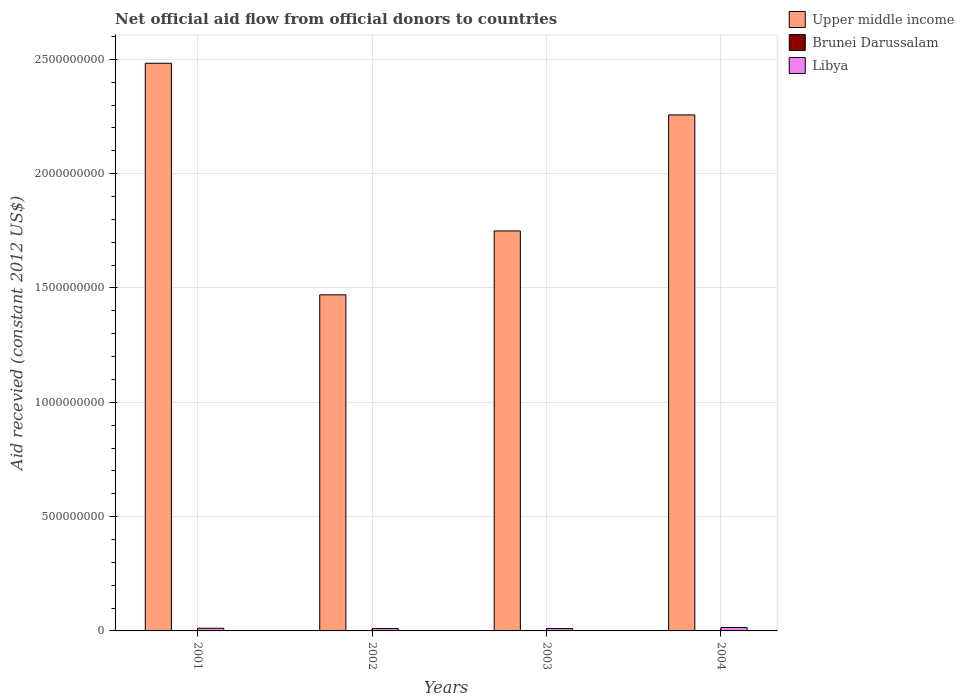In how many cases, is the number of bars for a given year not equal to the number of legend labels?
Ensure brevity in your answer.  1. What is the total aid received in Libya in 2001?
Provide a succinct answer. 1.17e+07. Across all years, what is the maximum total aid received in Libya?
Give a very brief answer. 1.50e+07. Across all years, what is the minimum total aid received in Libya?
Provide a short and direct response. 1.03e+07. In which year was the total aid received in Libya maximum?
Provide a succinct answer. 2004. What is the total total aid received in Brunei Darussalam in the graph?
Offer a terse response. 2.14e+06. What is the difference between the total aid received in Brunei Darussalam in 2001 and that in 2004?
Your answer should be very brief. -3.40e+05. What is the difference between the total aid received in Libya in 2003 and the total aid received in Brunei Darussalam in 2002?
Ensure brevity in your answer.  1.03e+07. What is the average total aid received in Brunei Darussalam per year?
Ensure brevity in your answer.  5.35e+05. In the year 2003, what is the difference between the total aid received in Brunei Darussalam and total aid received in Upper middle income?
Provide a succinct answer. -1.75e+09. What is the ratio of the total aid received in Upper middle income in 2001 to that in 2002?
Offer a very short reply. 1.69. What is the difference between the highest and the second highest total aid received in Brunei Darussalam?
Keep it short and to the point. 3.40e+05. What is the difference between the highest and the lowest total aid received in Brunei Darussalam?
Make the answer very short. 9.40e+05. How many bars are there?
Make the answer very short. 11. Are all the bars in the graph horizontal?
Your answer should be very brief. No. How many years are there in the graph?
Ensure brevity in your answer.  4. What is the difference between two consecutive major ticks on the Y-axis?
Provide a short and direct response. 5.00e+08. Where does the legend appear in the graph?
Keep it short and to the point. Top right. How many legend labels are there?
Keep it short and to the point. 3. What is the title of the graph?
Offer a terse response. Net official aid flow from official donors to countries. What is the label or title of the Y-axis?
Provide a succinct answer. Aid recevied (constant 2012 US$). What is the Aid recevied (constant 2012 US$) of Upper middle income in 2001?
Your answer should be very brief. 2.48e+09. What is the Aid recevied (constant 2012 US$) in Libya in 2001?
Make the answer very short. 1.17e+07. What is the Aid recevied (constant 2012 US$) in Upper middle income in 2002?
Ensure brevity in your answer.  1.47e+09. What is the Aid recevied (constant 2012 US$) in Brunei Darussalam in 2002?
Ensure brevity in your answer.  0. What is the Aid recevied (constant 2012 US$) of Libya in 2002?
Ensure brevity in your answer.  1.05e+07. What is the Aid recevied (constant 2012 US$) of Upper middle income in 2003?
Offer a terse response. 1.75e+09. What is the Aid recevied (constant 2012 US$) in Brunei Darussalam in 2003?
Make the answer very short. 6.00e+05. What is the Aid recevied (constant 2012 US$) of Libya in 2003?
Your response must be concise. 1.03e+07. What is the Aid recevied (constant 2012 US$) in Upper middle income in 2004?
Ensure brevity in your answer.  2.26e+09. What is the Aid recevied (constant 2012 US$) of Brunei Darussalam in 2004?
Your answer should be very brief. 9.40e+05. What is the Aid recevied (constant 2012 US$) of Libya in 2004?
Your answer should be compact. 1.50e+07. Across all years, what is the maximum Aid recevied (constant 2012 US$) of Upper middle income?
Your response must be concise. 2.48e+09. Across all years, what is the maximum Aid recevied (constant 2012 US$) of Brunei Darussalam?
Keep it short and to the point. 9.40e+05. Across all years, what is the maximum Aid recevied (constant 2012 US$) in Libya?
Offer a very short reply. 1.50e+07. Across all years, what is the minimum Aid recevied (constant 2012 US$) in Upper middle income?
Provide a succinct answer. 1.47e+09. Across all years, what is the minimum Aid recevied (constant 2012 US$) in Libya?
Give a very brief answer. 1.03e+07. What is the total Aid recevied (constant 2012 US$) in Upper middle income in the graph?
Provide a short and direct response. 7.96e+09. What is the total Aid recevied (constant 2012 US$) of Brunei Darussalam in the graph?
Provide a succinct answer. 2.14e+06. What is the total Aid recevied (constant 2012 US$) of Libya in the graph?
Offer a very short reply. 4.76e+07. What is the difference between the Aid recevied (constant 2012 US$) of Upper middle income in 2001 and that in 2002?
Give a very brief answer. 1.01e+09. What is the difference between the Aid recevied (constant 2012 US$) of Libya in 2001 and that in 2002?
Make the answer very short. 1.22e+06. What is the difference between the Aid recevied (constant 2012 US$) of Upper middle income in 2001 and that in 2003?
Your answer should be very brief. 7.33e+08. What is the difference between the Aid recevied (constant 2012 US$) in Libya in 2001 and that in 2003?
Provide a succinct answer. 1.39e+06. What is the difference between the Aid recevied (constant 2012 US$) in Upper middle income in 2001 and that in 2004?
Offer a very short reply. 2.26e+08. What is the difference between the Aid recevied (constant 2012 US$) of Libya in 2001 and that in 2004?
Make the answer very short. -3.28e+06. What is the difference between the Aid recevied (constant 2012 US$) of Upper middle income in 2002 and that in 2003?
Ensure brevity in your answer.  -2.79e+08. What is the difference between the Aid recevied (constant 2012 US$) of Upper middle income in 2002 and that in 2004?
Offer a terse response. -7.87e+08. What is the difference between the Aid recevied (constant 2012 US$) of Libya in 2002 and that in 2004?
Your response must be concise. -4.50e+06. What is the difference between the Aid recevied (constant 2012 US$) in Upper middle income in 2003 and that in 2004?
Ensure brevity in your answer.  -5.07e+08. What is the difference between the Aid recevied (constant 2012 US$) in Libya in 2003 and that in 2004?
Your answer should be compact. -4.67e+06. What is the difference between the Aid recevied (constant 2012 US$) in Upper middle income in 2001 and the Aid recevied (constant 2012 US$) in Libya in 2002?
Your answer should be very brief. 2.47e+09. What is the difference between the Aid recevied (constant 2012 US$) in Brunei Darussalam in 2001 and the Aid recevied (constant 2012 US$) in Libya in 2002?
Your answer should be compact. -9.91e+06. What is the difference between the Aid recevied (constant 2012 US$) in Upper middle income in 2001 and the Aid recevied (constant 2012 US$) in Brunei Darussalam in 2003?
Offer a very short reply. 2.48e+09. What is the difference between the Aid recevied (constant 2012 US$) of Upper middle income in 2001 and the Aid recevied (constant 2012 US$) of Libya in 2003?
Your answer should be very brief. 2.47e+09. What is the difference between the Aid recevied (constant 2012 US$) in Brunei Darussalam in 2001 and the Aid recevied (constant 2012 US$) in Libya in 2003?
Offer a terse response. -9.74e+06. What is the difference between the Aid recevied (constant 2012 US$) of Upper middle income in 2001 and the Aid recevied (constant 2012 US$) of Brunei Darussalam in 2004?
Offer a very short reply. 2.48e+09. What is the difference between the Aid recevied (constant 2012 US$) of Upper middle income in 2001 and the Aid recevied (constant 2012 US$) of Libya in 2004?
Keep it short and to the point. 2.47e+09. What is the difference between the Aid recevied (constant 2012 US$) of Brunei Darussalam in 2001 and the Aid recevied (constant 2012 US$) of Libya in 2004?
Ensure brevity in your answer.  -1.44e+07. What is the difference between the Aid recevied (constant 2012 US$) in Upper middle income in 2002 and the Aid recevied (constant 2012 US$) in Brunei Darussalam in 2003?
Your response must be concise. 1.47e+09. What is the difference between the Aid recevied (constant 2012 US$) of Upper middle income in 2002 and the Aid recevied (constant 2012 US$) of Libya in 2003?
Your response must be concise. 1.46e+09. What is the difference between the Aid recevied (constant 2012 US$) in Upper middle income in 2002 and the Aid recevied (constant 2012 US$) in Brunei Darussalam in 2004?
Make the answer very short. 1.47e+09. What is the difference between the Aid recevied (constant 2012 US$) in Upper middle income in 2002 and the Aid recevied (constant 2012 US$) in Libya in 2004?
Keep it short and to the point. 1.46e+09. What is the difference between the Aid recevied (constant 2012 US$) of Upper middle income in 2003 and the Aid recevied (constant 2012 US$) of Brunei Darussalam in 2004?
Keep it short and to the point. 1.75e+09. What is the difference between the Aid recevied (constant 2012 US$) of Upper middle income in 2003 and the Aid recevied (constant 2012 US$) of Libya in 2004?
Give a very brief answer. 1.73e+09. What is the difference between the Aid recevied (constant 2012 US$) in Brunei Darussalam in 2003 and the Aid recevied (constant 2012 US$) in Libya in 2004?
Provide a short and direct response. -1.44e+07. What is the average Aid recevied (constant 2012 US$) in Upper middle income per year?
Give a very brief answer. 1.99e+09. What is the average Aid recevied (constant 2012 US$) in Brunei Darussalam per year?
Keep it short and to the point. 5.35e+05. What is the average Aid recevied (constant 2012 US$) of Libya per year?
Provide a short and direct response. 1.19e+07. In the year 2001, what is the difference between the Aid recevied (constant 2012 US$) in Upper middle income and Aid recevied (constant 2012 US$) in Brunei Darussalam?
Make the answer very short. 2.48e+09. In the year 2001, what is the difference between the Aid recevied (constant 2012 US$) in Upper middle income and Aid recevied (constant 2012 US$) in Libya?
Provide a short and direct response. 2.47e+09. In the year 2001, what is the difference between the Aid recevied (constant 2012 US$) of Brunei Darussalam and Aid recevied (constant 2012 US$) of Libya?
Give a very brief answer. -1.11e+07. In the year 2002, what is the difference between the Aid recevied (constant 2012 US$) of Upper middle income and Aid recevied (constant 2012 US$) of Libya?
Offer a very short reply. 1.46e+09. In the year 2003, what is the difference between the Aid recevied (constant 2012 US$) in Upper middle income and Aid recevied (constant 2012 US$) in Brunei Darussalam?
Ensure brevity in your answer.  1.75e+09. In the year 2003, what is the difference between the Aid recevied (constant 2012 US$) of Upper middle income and Aid recevied (constant 2012 US$) of Libya?
Give a very brief answer. 1.74e+09. In the year 2003, what is the difference between the Aid recevied (constant 2012 US$) in Brunei Darussalam and Aid recevied (constant 2012 US$) in Libya?
Your response must be concise. -9.74e+06. In the year 2004, what is the difference between the Aid recevied (constant 2012 US$) of Upper middle income and Aid recevied (constant 2012 US$) of Brunei Darussalam?
Offer a terse response. 2.26e+09. In the year 2004, what is the difference between the Aid recevied (constant 2012 US$) of Upper middle income and Aid recevied (constant 2012 US$) of Libya?
Provide a succinct answer. 2.24e+09. In the year 2004, what is the difference between the Aid recevied (constant 2012 US$) of Brunei Darussalam and Aid recevied (constant 2012 US$) of Libya?
Provide a short and direct response. -1.41e+07. What is the ratio of the Aid recevied (constant 2012 US$) of Upper middle income in 2001 to that in 2002?
Keep it short and to the point. 1.69. What is the ratio of the Aid recevied (constant 2012 US$) in Libya in 2001 to that in 2002?
Your response must be concise. 1.12. What is the ratio of the Aid recevied (constant 2012 US$) of Upper middle income in 2001 to that in 2003?
Offer a very short reply. 1.42. What is the ratio of the Aid recevied (constant 2012 US$) in Libya in 2001 to that in 2003?
Your response must be concise. 1.13. What is the ratio of the Aid recevied (constant 2012 US$) in Upper middle income in 2001 to that in 2004?
Give a very brief answer. 1.1. What is the ratio of the Aid recevied (constant 2012 US$) in Brunei Darussalam in 2001 to that in 2004?
Offer a very short reply. 0.64. What is the ratio of the Aid recevied (constant 2012 US$) of Libya in 2001 to that in 2004?
Keep it short and to the point. 0.78. What is the ratio of the Aid recevied (constant 2012 US$) of Upper middle income in 2002 to that in 2003?
Make the answer very short. 0.84. What is the ratio of the Aid recevied (constant 2012 US$) of Libya in 2002 to that in 2003?
Provide a succinct answer. 1.02. What is the ratio of the Aid recevied (constant 2012 US$) in Upper middle income in 2002 to that in 2004?
Give a very brief answer. 0.65. What is the ratio of the Aid recevied (constant 2012 US$) in Libya in 2002 to that in 2004?
Offer a very short reply. 0.7. What is the ratio of the Aid recevied (constant 2012 US$) in Upper middle income in 2003 to that in 2004?
Provide a short and direct response. 0.78. What is the ratio of the Aid recevied (constant 2012 US$) in Brunei Darussalam in 2003 to that in 2004?
Offer a terse response. 0.64. What is the ratio of the Aid recevied (constant 2012 US$) of Libya in 2003 to that in 2004?
Offer a very short reply. 0.69. What is the difference between the highest and the second highest Aid recevied (constant 2012 US$) in Upper middle income?
Your response must be concise. 2.26e+08. What is the difference between the highest and the second highest Aid recevied (constant 2012 US$) of Libya?
Your response must be concise. 3.28e+06. What is the difference between the highest and the lowest Aid recevied (constant 2012 US$) in Upper middle income?
Provide a short and direct response. 1.01e+09. What is the difference between the highest and the lowest Aid recevied (constant 2012 US$) of Brunei Darussalam?
Give a very brief answer. 9.40e+05. What is the difference between the highest and the lowest Aid recevied (constant 2012 US$) in Libya?
Make the answer very short. 4.67e+06. 